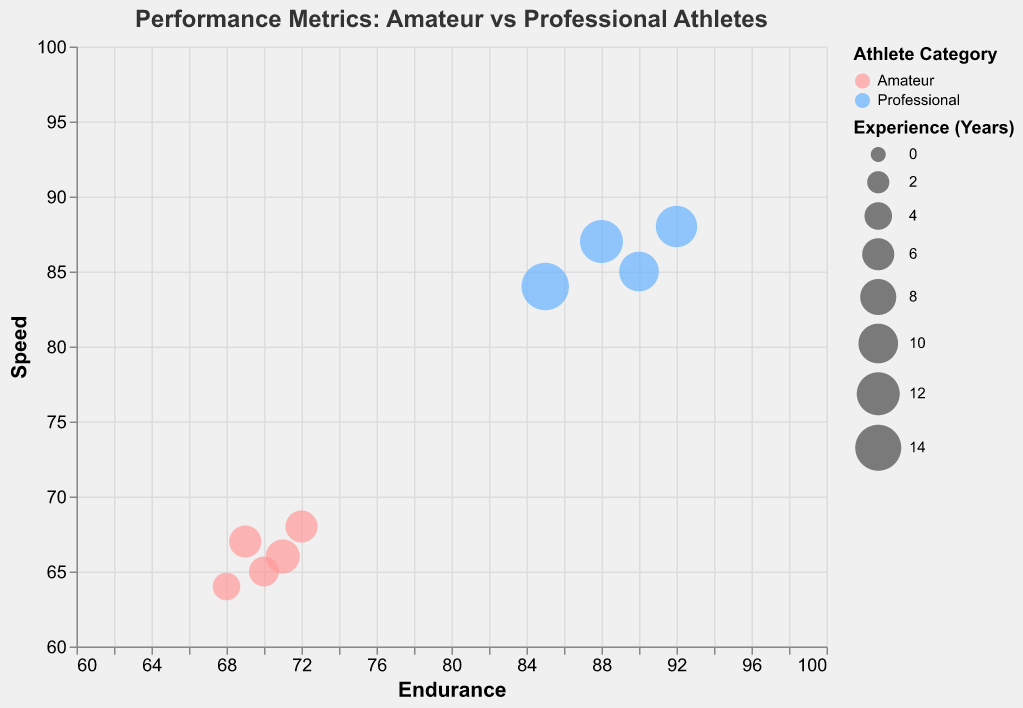What is the title of the figure? The title is placed at the top center of the figure and is often the largest and boldest text to catch attention immediately.
Answer: "Performance Metrics: Amateur vs Professional Athletes" How many data points represent Professional athletes? Count all the circles (bubbles) colored in one of the categories, such as the light blue color representing Professional athletes.
Answer: 4 Which athlete has the highest Speed value? Look for the bubble with the highest y-coordinate (Speed) and find the tooltip or color representing that athlete.
Answer: Alice Brown What is the size range used to represent Experience Years? The size legend indicates the range of values represented by circle sizes. Look at the legend for this information.
Answer: 100 to 1000 Compare the average Endurance of Amateur athletes to that of Professional athletes. Which has a higher average? Calculate the average Endurance score for both groups separately and then compare the two averages.
Answer: Professionals Which category of athletes generally has more Experience Years represented by larger bubble sizes? Observe the size differences of the bubbles and note which category (color) exhibits generally larger or smaller bubbles.
Answer: Professional What is the endurance difference between the athletes with the highest and lowest endurance? Identify the highest and lowest Endurance values on the x-axis, then compute their difference.
Answer: 24 Are all Professional athletes faster than Amateur athletes? Compare the Speed values (y-axis) of all Professional athletes with all Amateur ones to see if all Professionals have higher values.
Answer: Yes Which group shows greater variation in Speed: Amateurs or Professionals? Look at the spread of the bubbles along the y-axis (Speed) for each category, observing which has a wider distribution.
Answer: Amateurs What does the bubble size represent in this figure? Refer to the legend that identifies what each bubble's size corresponds to.
Answer: Experience Years 